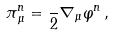Convert formula to latex. <formula><loc_0><loc_0><loc_500><loc_500>\pi ^ { n } _ { \, \mu } = \frac { } { 2 } \nabla _ { \mu } \varphi ^ { n } \, ,</formula> 